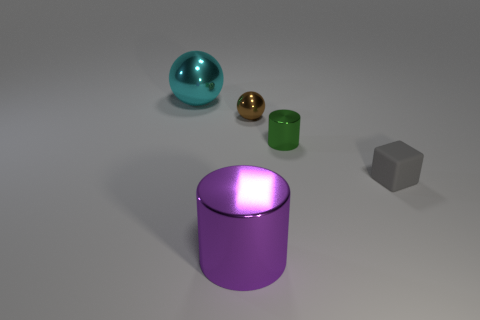Is the ball that is behind the brown shiny sphere made of the same material as the tiny ball?
Your answer should be compact. Yes. What color is the other metallic object that is the same shape as the cyan metal thing?
Ensure brevity in your answer.  Brown. There is a large object in front of the small gray rubber object; does it have the same shape as the object to the left of the big cylinder?
Your answer should be compact. No. How many blocks are either rubber things or large purple metal things?
Your answer should be very brief. 1. Are there fewer large things on the right side of the cube than large red rubber blocks?
Provide a succinct answer. No. What number of other things are there of the same material as the brown object
Provide a short and direct response. 3. Do the matte cube and the brown object have the same size?
Offer a terse response. Yes. What number of things are large metal things that are in front of the small cube or large cylinders?
Your answer should be compact. 1. The sphere that is on the right side of the big shiny thing that is behind the tiny cube is made of what material?
Provide a short and direct response. Metal. Are there any big purple metal objects of the same shape as the tiny gray matte thing?
Keep it short and to the point. No. 